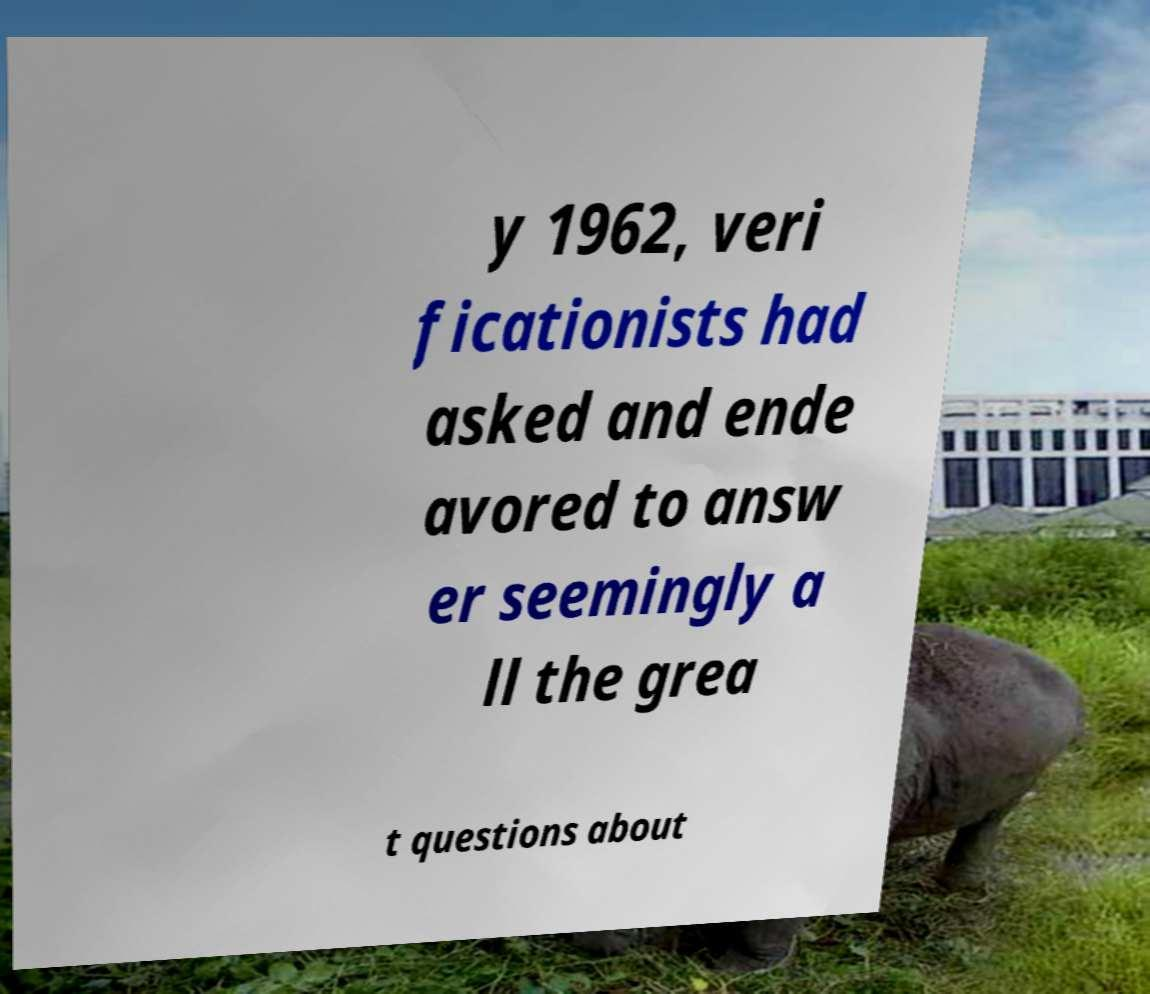Please read and relay the text visible in this image. What does it say? y 1962, veri ficationists had asked and ende avored to answ er seemingly a ll the grea t questions about 